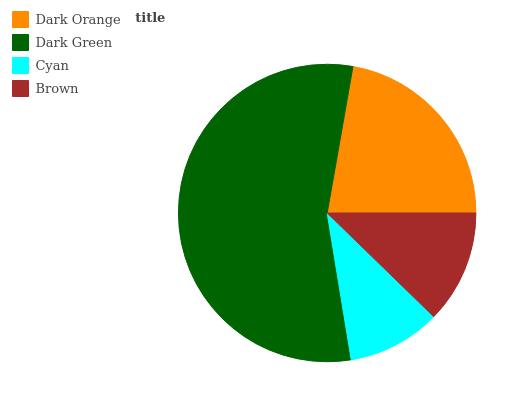Is Cyan the minimum?
Answer yes or no. Yes. Is Dark Green the maximum?
Answer yes or no. Yes. Is Dark Green the minimum?
Answer yes or no. No. Is Cyan the maximum?
Answer yes or no. No. Is Dark Green greater than Cyan?
Answer yes or no. Yes. Is Cyan less than Dark Green?
Answer yes or no. Yes. Is Cyan greater than Dark Green?
Answer yes or no. No. Is Dark Green less than Cyan?
Answer yes or no. No. Is Dark Orange the high median?
Answer yes or no. Yes. Is Brown the low median?
Answer yes or no. Yes. Is Brown the high median?
Answer yes or no. No. Is Cyan the low median?
Answer yes or no. No. 